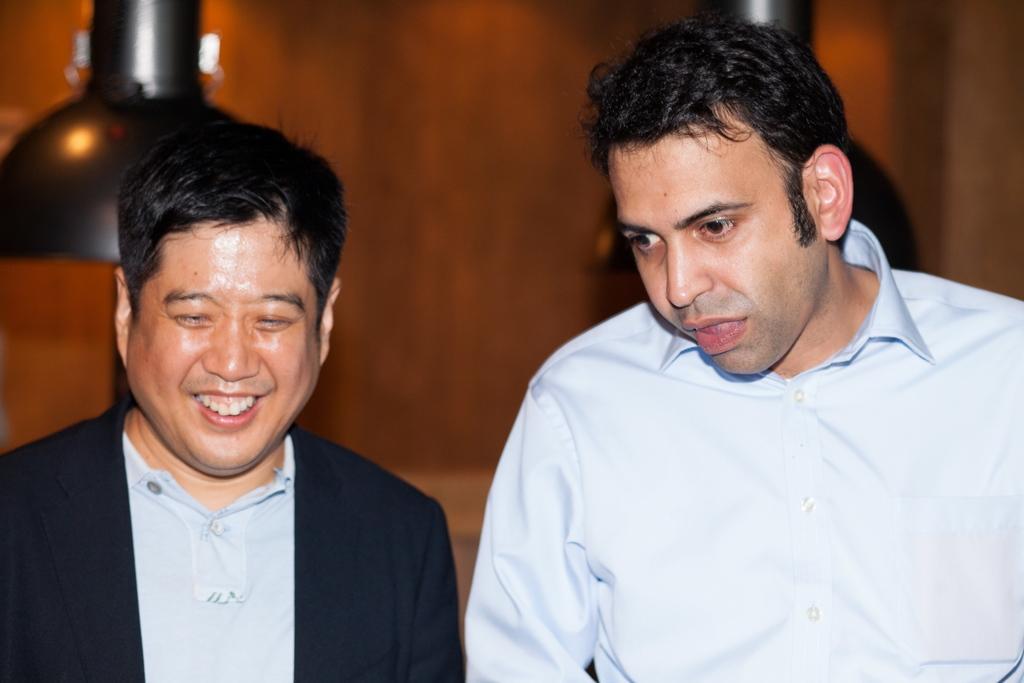Can you describe this image briefly? In the image we can see two men wearing clothes and the left side man is smiling, and the background is blurred. 